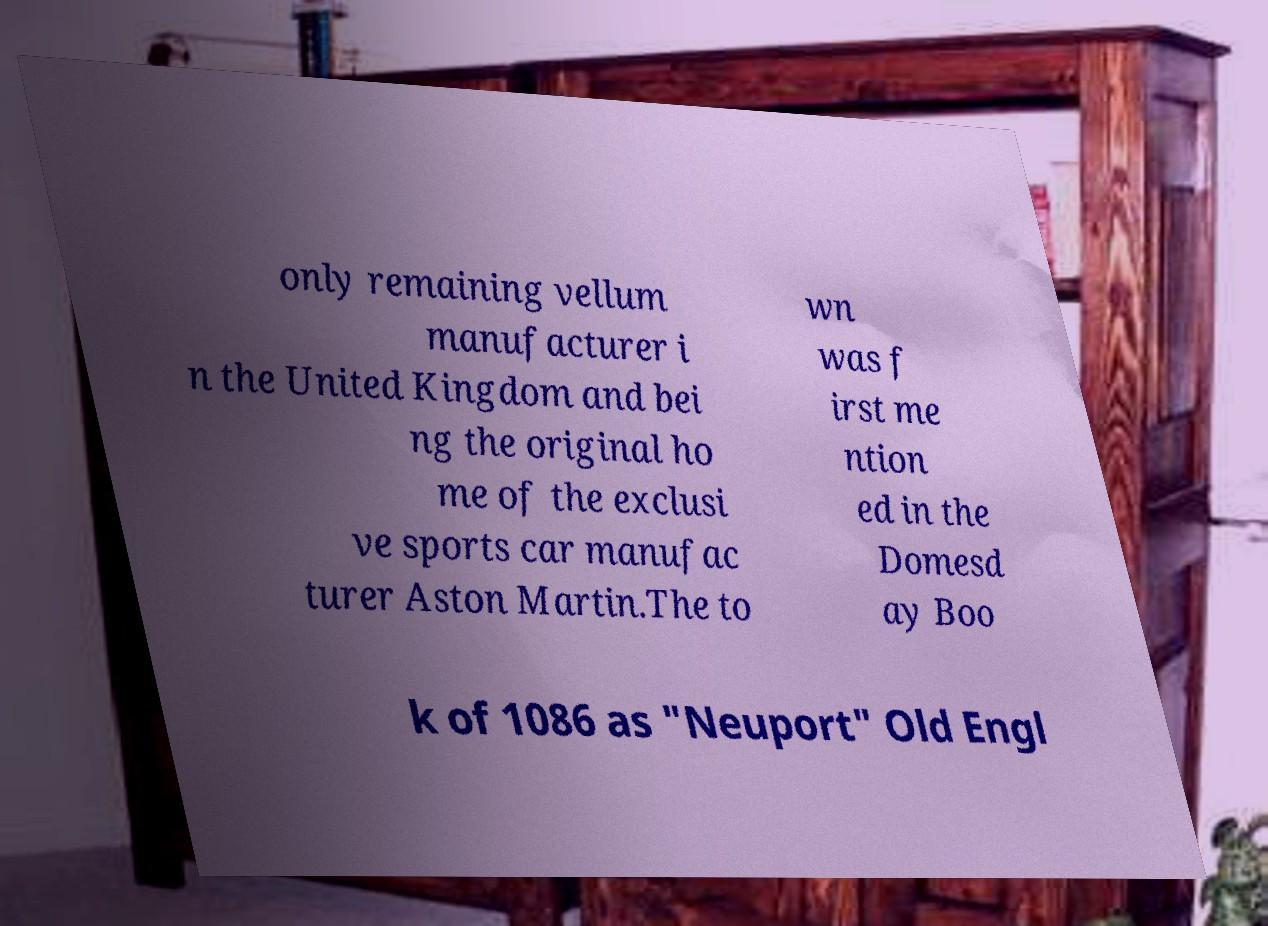Could you extract and type out the text from this image? only remaining vellum manufacturer i n the United Kingdom and bei ng the original ho me of the exclusi ve sports car manufac turer Aston Martin.The to wn was f irst me ntion ed in the Domesd ay Boo k of 1086 as "Neuport" Old Engl 